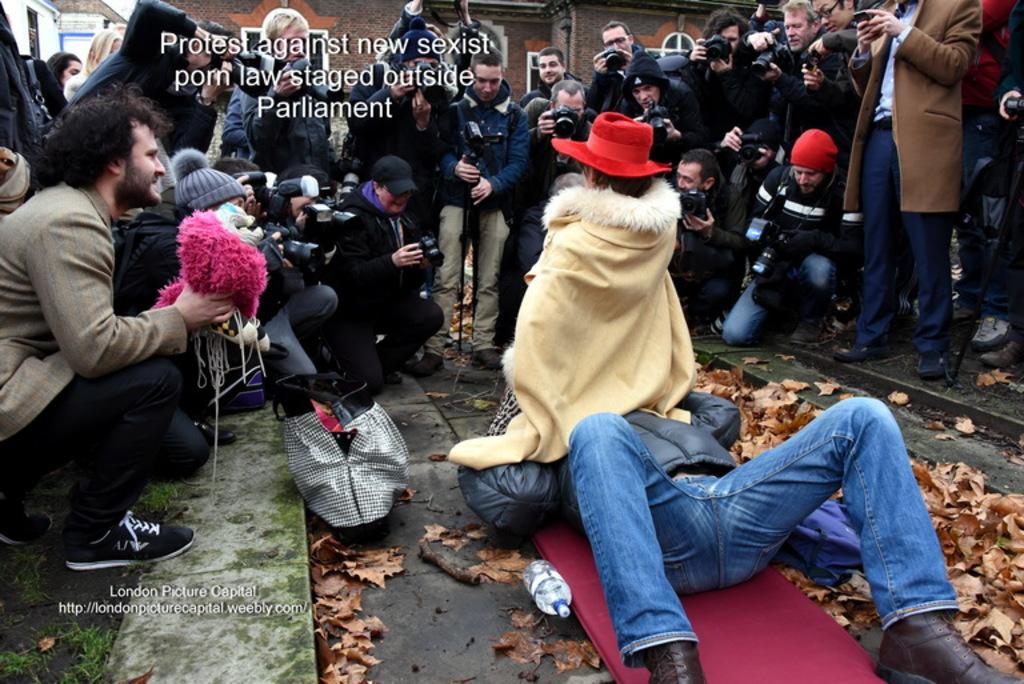In one or two sentences, can you explain what this image depicts? In this picture we can see a group of people are standing and some of them are sitting and some of them are holding cameras. In the center of the image we can see a man is lying on the floor and also we can see a person is sitting on a man and wearing costume, hat. In the background of the image we can see the floor, bag, dry leaves, bottle, mat, grass, text. At the top of the image we can see the buildings, windows, wall. On the left side of the image we can see a man is sitting on his knees and holding an object and also we can see the text. 